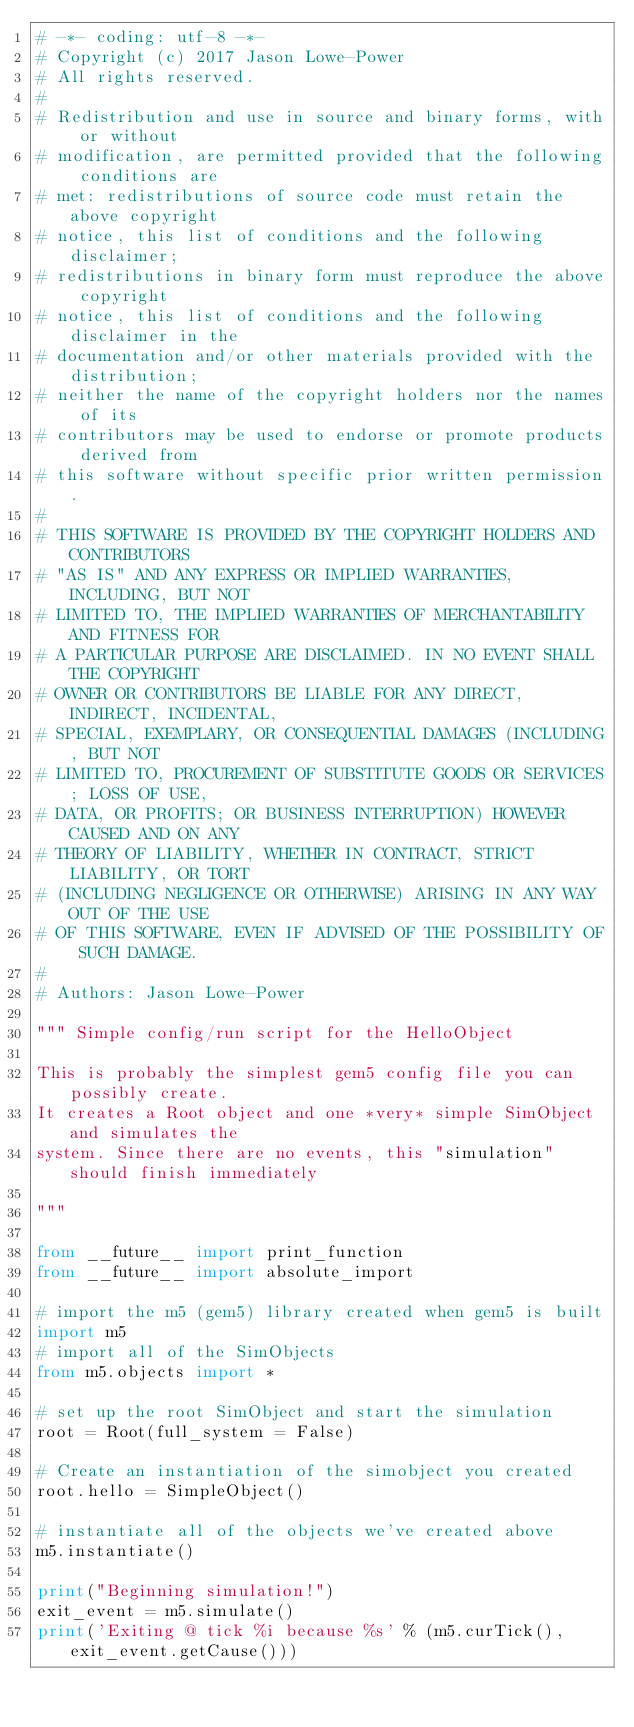Convert code to text. <code><loc_0><loc_0><loc_500><loc_500><_Python_># -*- coding: utf-8 -*-
# Copyright (c) 2017 Jason Lowe-Power
# All rights reserved.
#
# Redistribution and use in source and binary forms, with or without
# modification, are permitted provided that the following conditions are
# met: redistributions of source code must retain the above copyright
# notice, this list of conditions and the following disclaimer;
# redistributions in binary form must reproduce the above copyright
# notice, this list of conditions and the following disclaimer in the
# documentation and/or other materials provided with the distribution;
# neither the name of the copyright holders nor the names of its
# contributors may be used to endorse or promote products derived from
# this software without specific prior written permission.
#
# THIS SOFTWARE IS PROVIDED BY THE COPYRIGHT HOLDERS AND CONTRIBUTORS
# "AS IS" AND ANY EXPRESS OR IMPLIED WARRANTIES, INCLUDING, BUT NOT
# LIMITED TO, THE IMPLIED WARRANTIES OF MERCHANTABILITY AND FITNESS FOR
# A PARTICULAR PURPOSE ARE DISCLAIMED. IN NO EVENT SHALL THE COPYRIGHT
# OWNER OR CONTRIBUTORS BE LIABLE FOR ANY DIRECT, INDIRECT, INCIDENTAL,
# SPECIAL, EXEMPLARY, OR CONSEQUENTIAL DAMAGES (INCLUDING, BUT NOT
# LIMITED TO, PROCUREMENT OF SUBSTITUTE GOODS OR SERVICES; LOSS OF USE,
# DATA, OR PROFITS; OR BUSINESS INTERRUPTION) HOWEVER CAUSED AND ON ANY
# THEORY OF LIABILITY, WHETHER IN CONTRACT, STRICT LIABILITY, OR TORT
# (INCLUDING NEGLIGENCE OR OTHERWISE) ARISING IN ANY WAY OUT OF THE USE
# OF THIS SOFTWARE, EVEN IF ADVISED OF THE POSSIBILITY OF SUCH DAMAGE.
#
# Authors: Jason Lowe-Power

""" Simple config/run script for the HelloObject

This is probably the simplest gem5 config file you can possibly create.
It creates a Root object and one *very* simple SimObject and simulates the
system. Since there are no events, this "simulation" should finish immediately

"""

from __future__ import print_function
from __future__ import absolute_import

# import the m5 (gem5) library created when gem5 is built
import m5
# import all of the SimObjects
from m5.objects import *

# set up the root SimObject and start the simulation
root = Root(full_system = False)

# Create an instantiation of the simobject you created
root.hello = SimpleObject()

# instantiate all of the objects we've created above
m5.instantiate()

print("Beginning simulation!")
exit_event = m5.simulate()
print('Exiting @ tick %i because %s' % (m5.curTick(), exit_event.getCause()))
</code> 